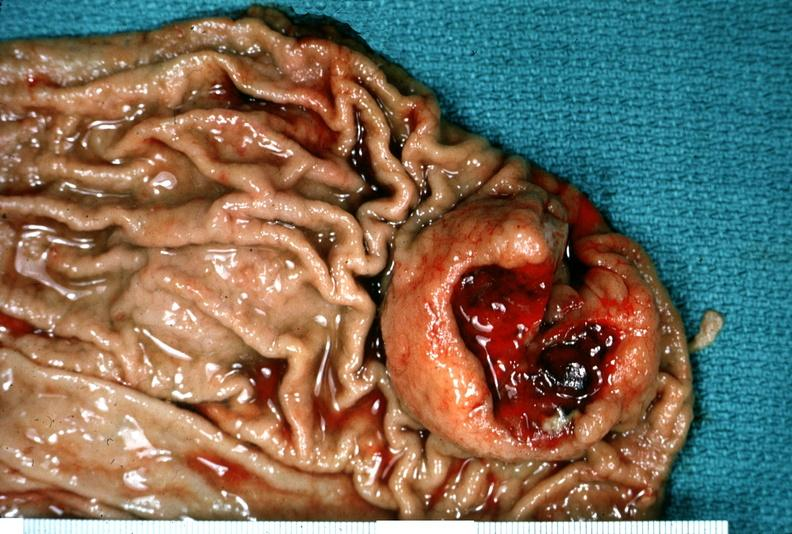where does this belong to?
Answer the question using a single word or phrase. Gastrointestinal system 